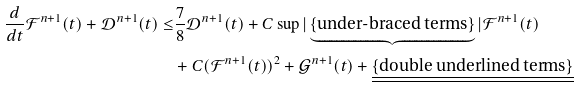<formula> <loc_0><loc_0><loc_500><loc_500>\frac { d } { d t } \mathcal { F } ^ { n + 1 } ( t ) + \mathcal { D } ^ { n + 1 } ( t ) \leq & \frac { 7 } { 8 } \mathcal { D } ^ { n + 1 } ( t ) + C \sup | \underbrace { \{ \text {under-braced terms} \} } | \mathcal { F } ^ { n + 1 } ( t ) \\ & + C ( \mathcal { F } ^ { n + 1 } ( t ) ) ^ { 2 } + \mathcal { G } ^ { n + 1 } ( t ) + \underline { \underline { \{ \text {double underlined terms} \} } }</formula> 